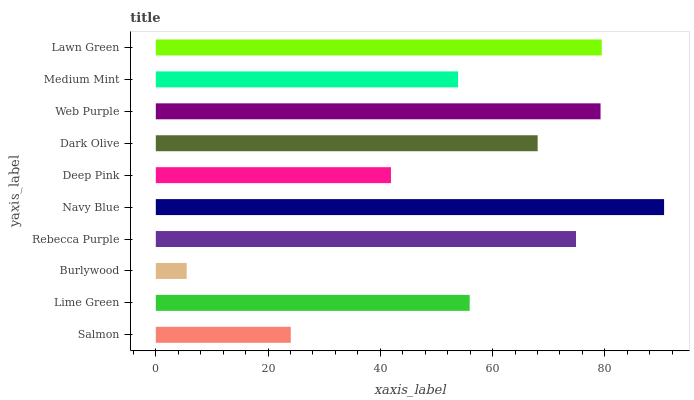Is Burlywood the minimum?
Answer yes or no. Yes. Is Navy Blue the maximum?
Answer yes or no. Yes. Is Lime Green the minimum?
Answer yes or no. No. Is Lime Green the maximum?
Answer yes or no. No. Is Lime Green greater than Salmon?
Answer yes or no. Yes. Is Salmon less than Lime Green?
Answer yes or no. Yes. Is Salmon greater than Lime Green?
Answer yes or no. No. Is Lime Green less than Salmon?
Answer yes or no. No. Is Dark Olive the high median?
Answer yes or no. Yes. Is Lime Green the low median?
Answer yes or no. Yes. Is Lawn Green the high median?
Answer yes or no. No. Is Burlywood the low median?
Answer yes or no. No. 